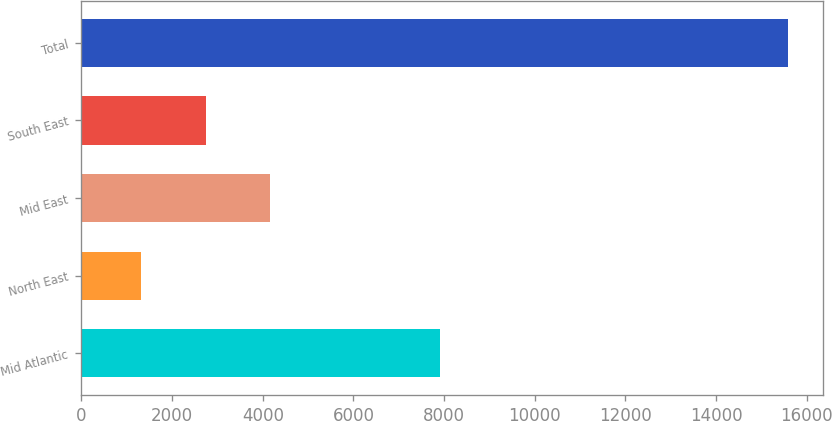<chart> <loc_0><loc_0><loc_500><loc_500><bar_chart><fcel>Mid Atlantic<fcel>North East<fcel>Mid East<fcel>South East<fcel>Total<nl><fcel>7916<fcel>1314<fcel>4167.8<fcel>2740.9<fcel>15583<nl></chart> 